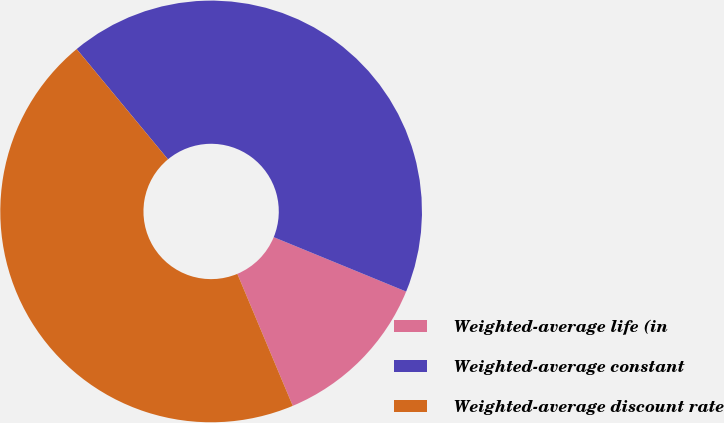<chart> <loc_0><loc_0><loc_500><loc_500><pie_chart><fcel>Weighted-average life (in<fcel>Weighted-average constant<fcel>Weighted-average discount rate<nl><fcel>12.47%<fcel>42.21%<fcel>45.32%<nl></chart> 